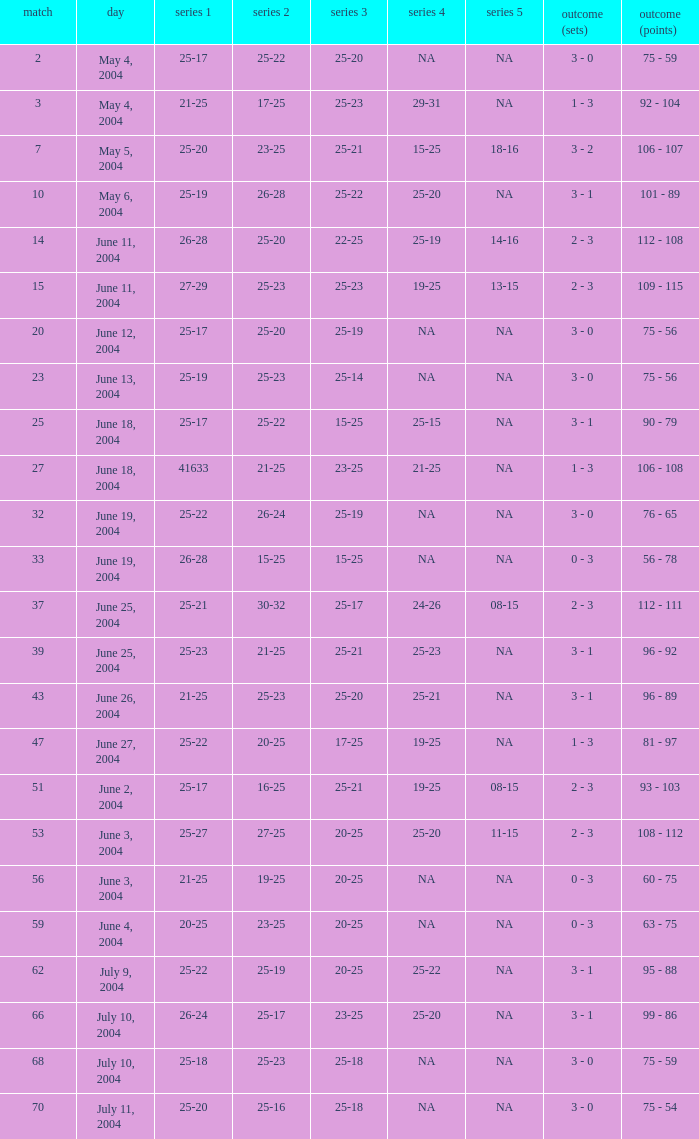Can you parse all the data within this table? {'header': ['match', 'day', 'series 1', 'series 2', 'series 3', 'series 4', 'series 5', 'outcome (sets)', 'outcome (points)'], 'rows': [['2', 'May 4, 2004', '25-17', '25-22', '25-20', 'NA', 'NA', '3 - 0', '75 - 59'], ['3', 'May 4, 2004', '21-25', '17-25', '25-23', '29-31', 'NA', '1 - 3', '92 - 104'], ['7', 'May 5, 2004', '25-20', '23-25', '25-21', '15-25', '18-16', '3 - 2', '106 - 107'], ['10', 'May 6, 2004', '25-19', '26-28', '25-22', '25-20', 'NA', '3 - 1', '101 - 89'], ['14', 'June 11, 2004', '26-28', '25-20', '22-25', '25-19', '14-16', '2 - 3', '112 - 108'], ['15', 'June 11, 2004', '27-29', '25-23', '25-23', '19-25', '13-15', '2 - 3', '109 - 115'], ['20', 'June 12, 2004', '25-17', '25-20', '25-19', 'NA', 'NA', '3 - 0', '75 - 56'], ['23', 'June 13, 2004', '25-19', '25-23', '25-14', 'NA', 'NA', '3 - 0', '75 - 56'], ['25', 'June 18, 2004', '25-17', '25-22', '15-25', '25-15', 'NA', '3 - 1', '90 - 79'], ['27', 'June 18, 2004', '41633', '21-25', '23-25', '21-25', 'NA', '1 - 3', '106 - 108'], ['32', 'June 19, 2004', '25-22', '26-24', '25-19', 'NA', 'NA', '3 - 0', '76 - 65'], ['33', 'June 19, 2004', '26-28', '15-25', '15-25', 'NA', 'NA', '0 - 3', '56 - 78'], ['37', 'June 25, 2004', '25-21', '30-32', '25-17', '24-26', '08-15', '2 - 3', '112 - 111'], ['39', 'June 25, 2004', '25-23', '21-25', '25-21', '25-23', 'NA', '3 - 1', '96 - 92'], ['43', 'June 26, 2004', '21-25', '25-23', '25-20', '25-21', 'NA', '3 - 1', '96 - 89'], ['47', 'June 27, 2004', '25-22', '20-25', '17-25', '19-25', 'NA', '1 - 3', '81 - 97'], ['51', 'June 2, 2004', '25-17', '16-25', '25-21', '19-25', '08-15', '2 - 3', '93 - 103'], ['53', 'June 3, 2004', '25-27', '27-25', '20-25', '25-20', '11-15', '2 - 3', '108 - 112'], ['56', 'June 3, 2004', '21-25', '19-25', '20-25', 'NA', 'NA', '0 - 3', '60 - 75'], ['59', 'June 4, 2004', '20-25', '23-25', '20-25', 'NA', 'NA', '0 - 3', '63 - 75'], ['62', 'July 9, 2004', '25-22', '25-19', '20-25', '25-22', 'NA', '3 - 1', '95 - 88'], ['66', 'July 10, 2004', '26-24', '25-17', '23-25', '25-20', 'NA', '3 - 1', '99 - 86'], ['68', 'July 10, 2004', '25-18', '25-23', '25-18', 'NA', 'NA', '3 - 0', '75 - 59'], ['70', 'July 11, 2004', '25-20', '25-16', '25-18', 'NA', 'NA', '3 - 0', '75 - 54']]} What is the result of the game with a set 1 of 26-24? 99 - 86. 